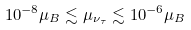Convert formula to latex. <formula><loc_0><loc_0><loc_500><loc_500>1 0 ^ { - 8 } \mu _ { B } \lesssim \mu _ { \nu _ { \tau } } \lesssim 1 0 ^ { - 6 } \mu _ { B }</formula> 